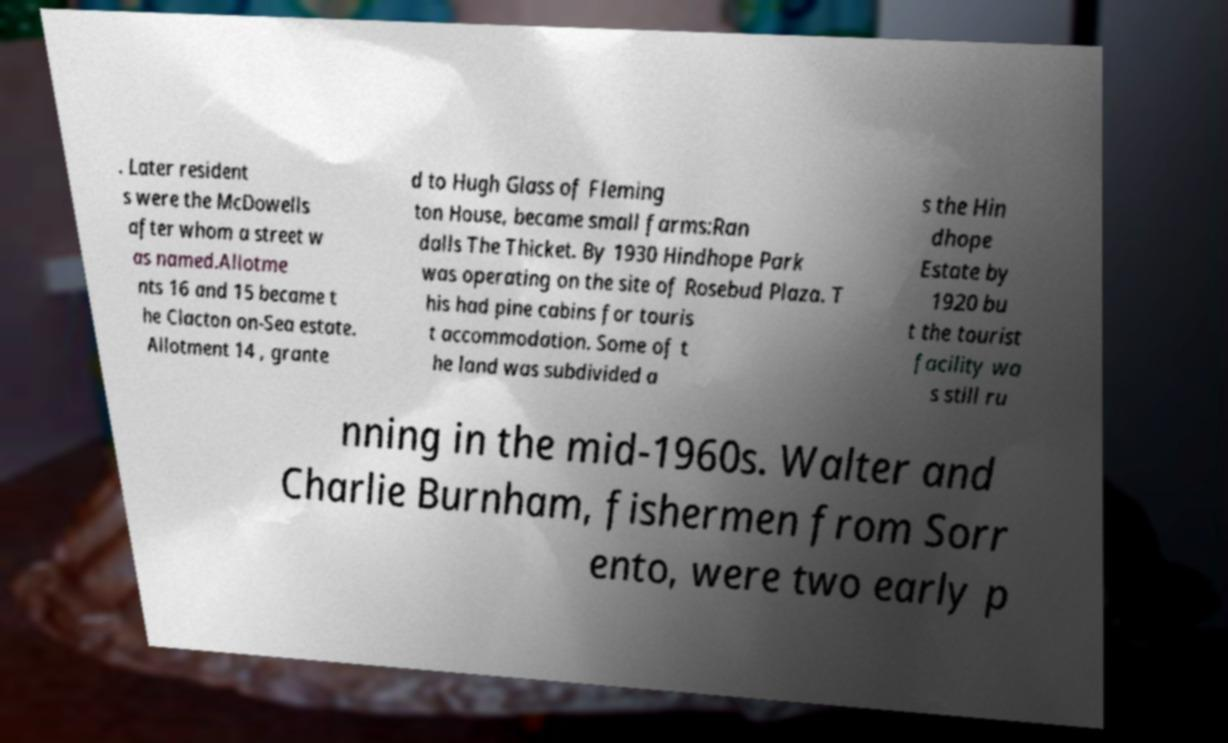Can you read and provide the text displayed in the image?This photo seems to have some interesting text. Can you extract and type it out for me? . Later resident s were the McDowells after whom a street w as named.Allotme nts 16 and 15 became t he Clacton on-Sea estate. Allotment 14 , grante d to Hugh Glass of Fleming ton House, became small farms:Ran dalls The Thicket. By 1930 Hindhope Park was operating on the site of Rosebud Plaza. T his had pine cabins for touris t accommodation. Some of t he land was subdivided a s the Hin dhope Estate by 1920 bu t the tourist facility wa s still ru nning in the mid-1960s. Walter and Charlie Burnham, fishermen from Sorr ento, were two early p 